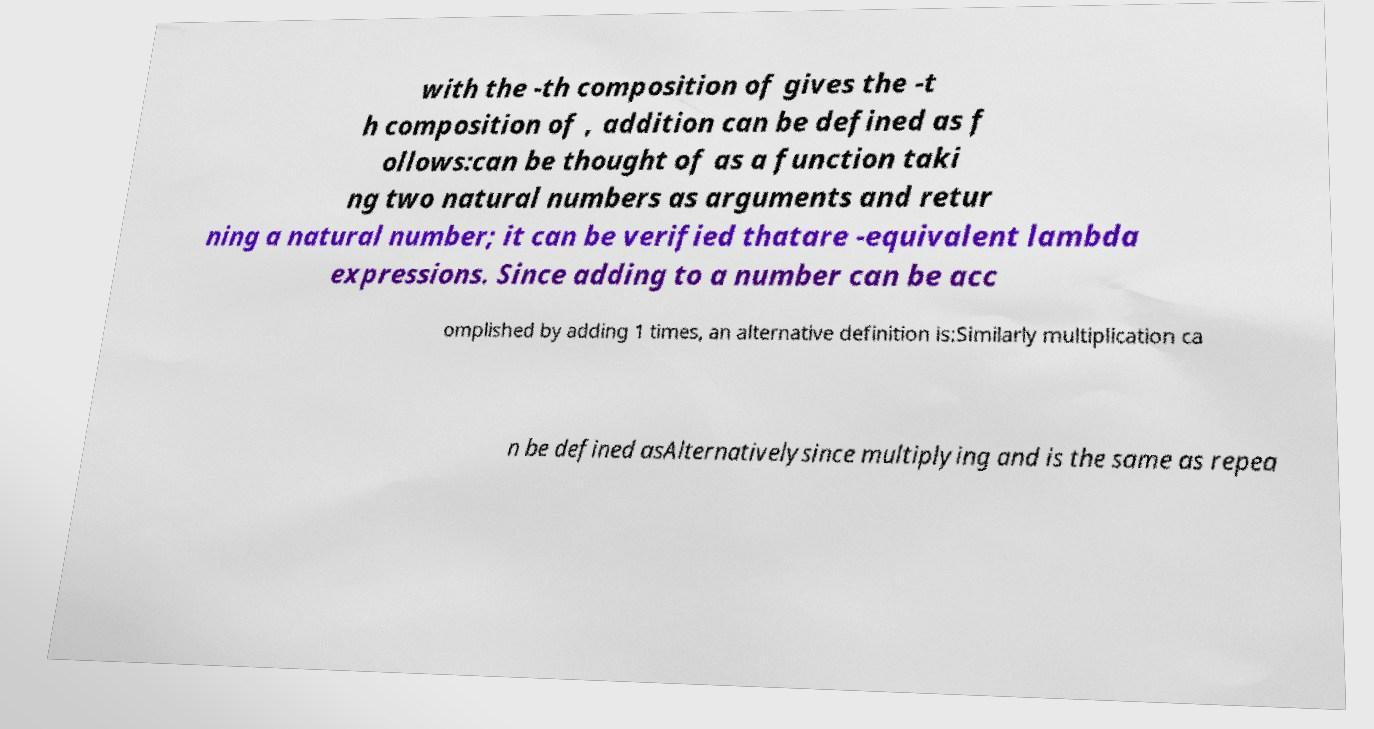I need the written content from this picture converted into text. Can you do that? with the -th composition of gives the -t h composition of , addition can be defined as f ollows:can be thought of as a function taki ng two natural numbers as arguments and retur ning a natural number; it can be verified thatare -equivalent lambda expressions. Since adding to a number can be acc omplished by adding 1 times, an alternative definition is:Similarly multiplication ca n be defined asAlternativelysince multiplying and is the same as repea 